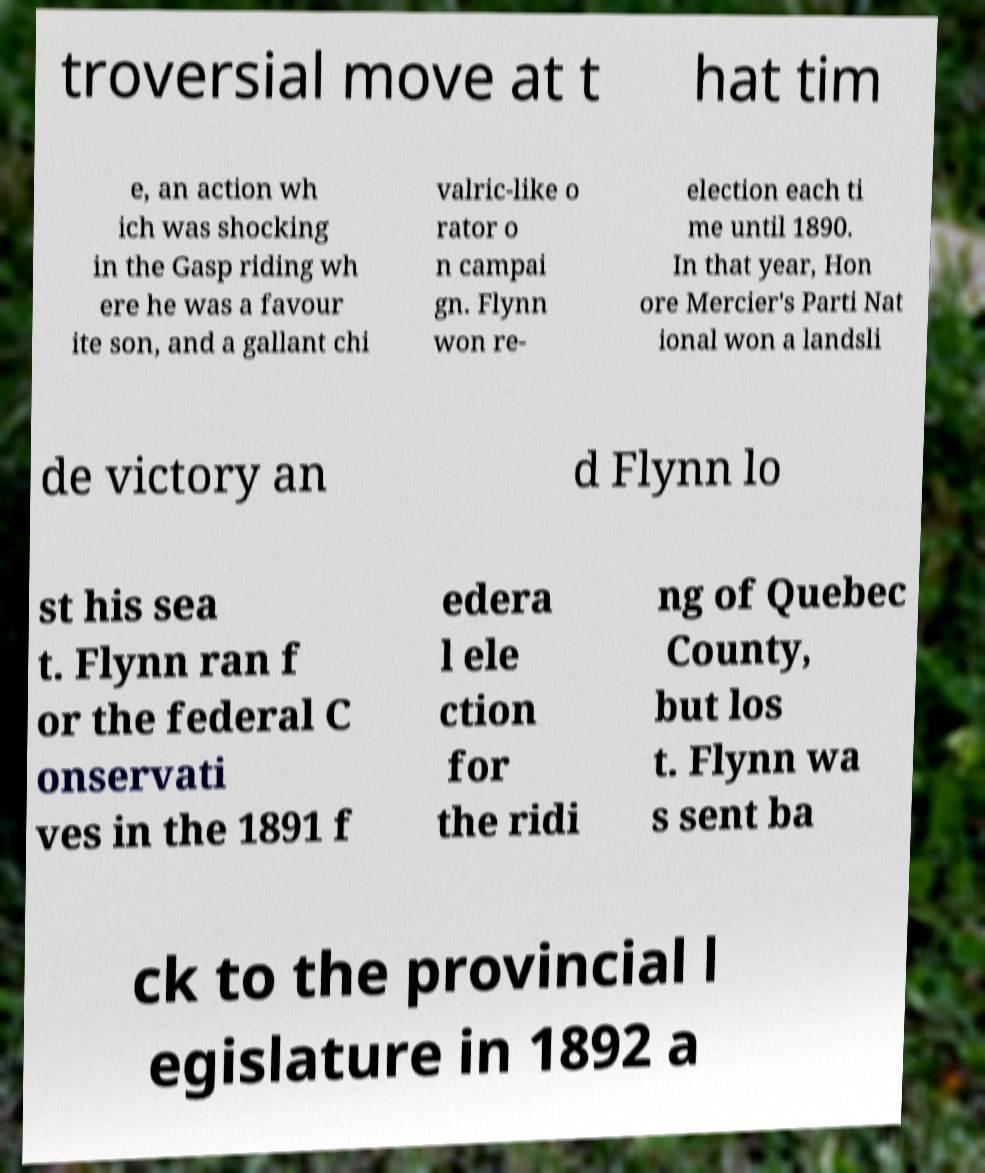There's text embedded in this image that I need extracted. Can you transcribe it verbatim? troversial move at t hat tim e, an action wh ich was shocking in the Gasp riding wh ere he was a favour ite son, and a gallant chi valric-like o rator o n campai gn. Flynn won re- election each ti me until 1890. In that year, Hon ore Mercier's Parti Nat ional won a landsli de victory an d Flynn lo st his sea t. Flynn ran f or the federal C onservati ves in the 1891 f edera l ele ction for the ridi ng of Quebec County, but los t. Flynn wa s sent ba ck to the provincial l egislature in 1892 a 